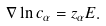Convert formula to latex. <formula><loc_0><loc_0><loc_500><loc_500>\nabla \ln c _ { \alpha } = z _ { \alpha } E .</formula> 